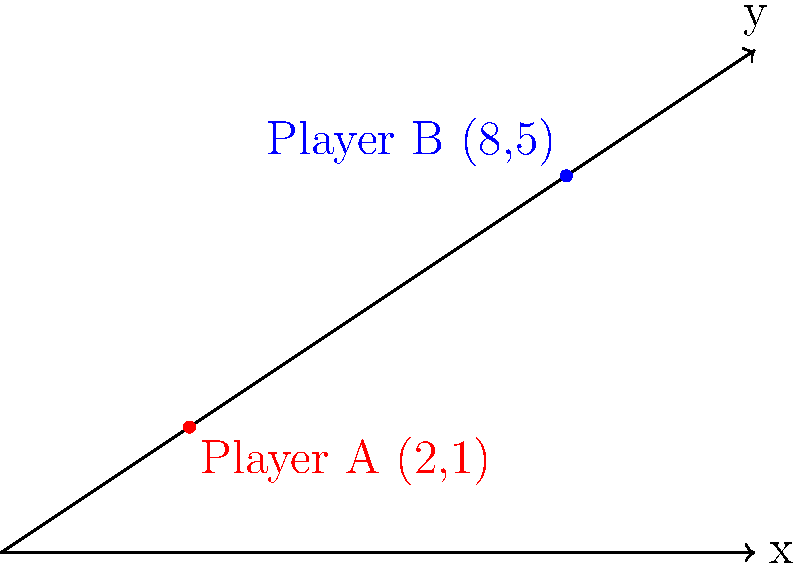During a Crystal Palace match, you're analyzing the positions of two players on the field using a coordinate system. Player A is at position (2,1), and Player B is at (8,5). What is the distance between these two players? Let's solve this step-by-step using the distance formula between two points:

1) The distance formula is:
   $$d = \sqrt{(x_2-x_1)^2 + (y_2-y_1)^2}$$

2) We have:
   Player A: $(x_1, y_1) = (2, 1)$
   Player B: $(x_2, y_2) = (8, 5)$

3) Let's substitute these into the formula:
   $$d = \sqrt{(8-2)^2 + (5-1)^2}$$

4) Simplify inside the parentheses:
   $$d = \sqrt{6^2 + 4^2}$$

5) Calculate the squares:
   $$d = \sqrt{36 + 16}$$

6) Add inside the square root:
   $$d = \sqrt{52}$$

7) Simplify the square root:
   $$d = 2\sqrt{13}$$

Therefore, the distance between the two players is $2\sqrt{13}$ units.
Answer: $2\sqrt{13}$ units 